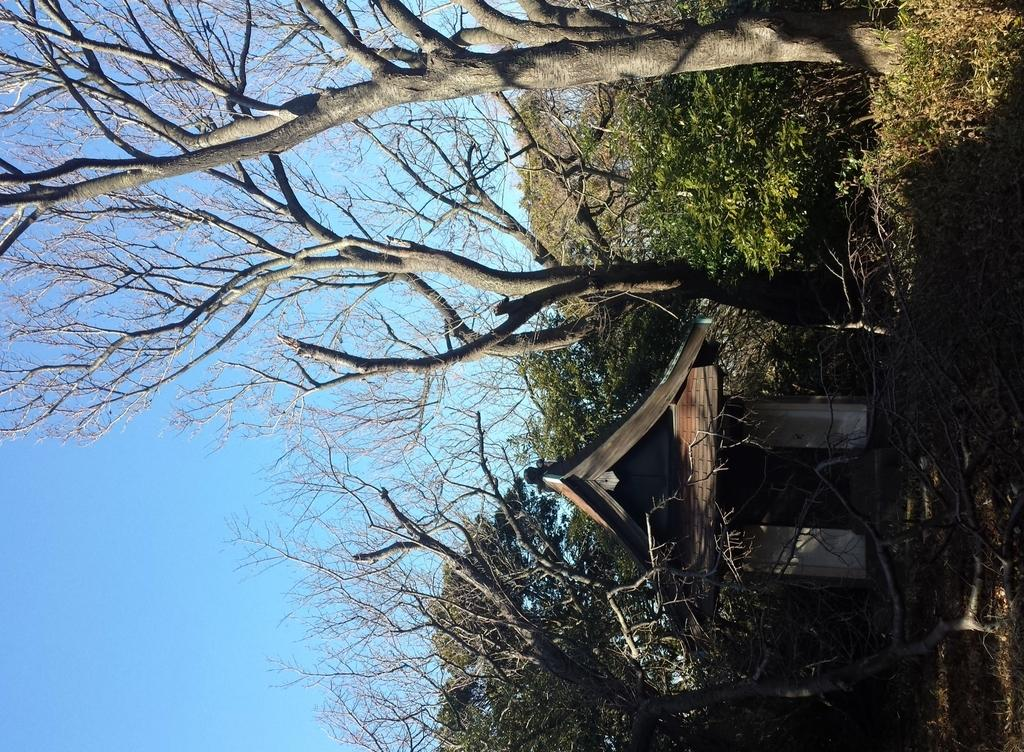What type of structure is present in the image? There is a hut in the image. What can be seen behind the hut? There are trees behind the hut. What is visible in the background of the image? The sky is visible in the image. Where are the plants located in the image? The plants are in the top right corner of the image. What type of ornament is hanging from the roof of the hut in the image? There is no ornament hanging from the roof of the hut in the image. What is the fork used for in the image? There is no fork present in the image. 